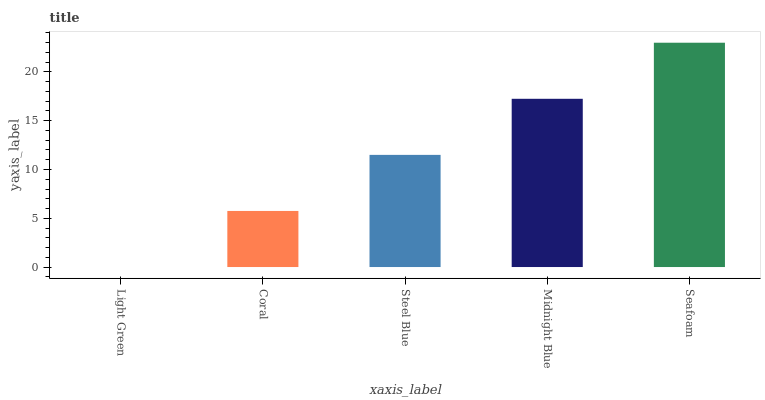Is Light Green the minimum?
Answer yes or no. Yes. Is Seafoam the maximum?
Answer yes or no. Yes. Is Coral the minimum?
Answer yes or no. No. Is Coral the maximum?
Answer yes or no. No. Is Coral greater than Light Green?
Answer yes or no. Yes. Is Light Green less than Coral?
Answer yes or no. Yes. Is Light Green greater than Coral?
Answer yes or no. No. Is Coral less than Light Green?
Answer yes or no. No. Is Steel Blue the high median?
Answer yes or no. Yes. Is Steel Blue the low median?
Answer yes or no. Yes. Is Seafoam the high median?
Answer yes or no. No. Is Coral the low median?
Answer yes or no. No. 